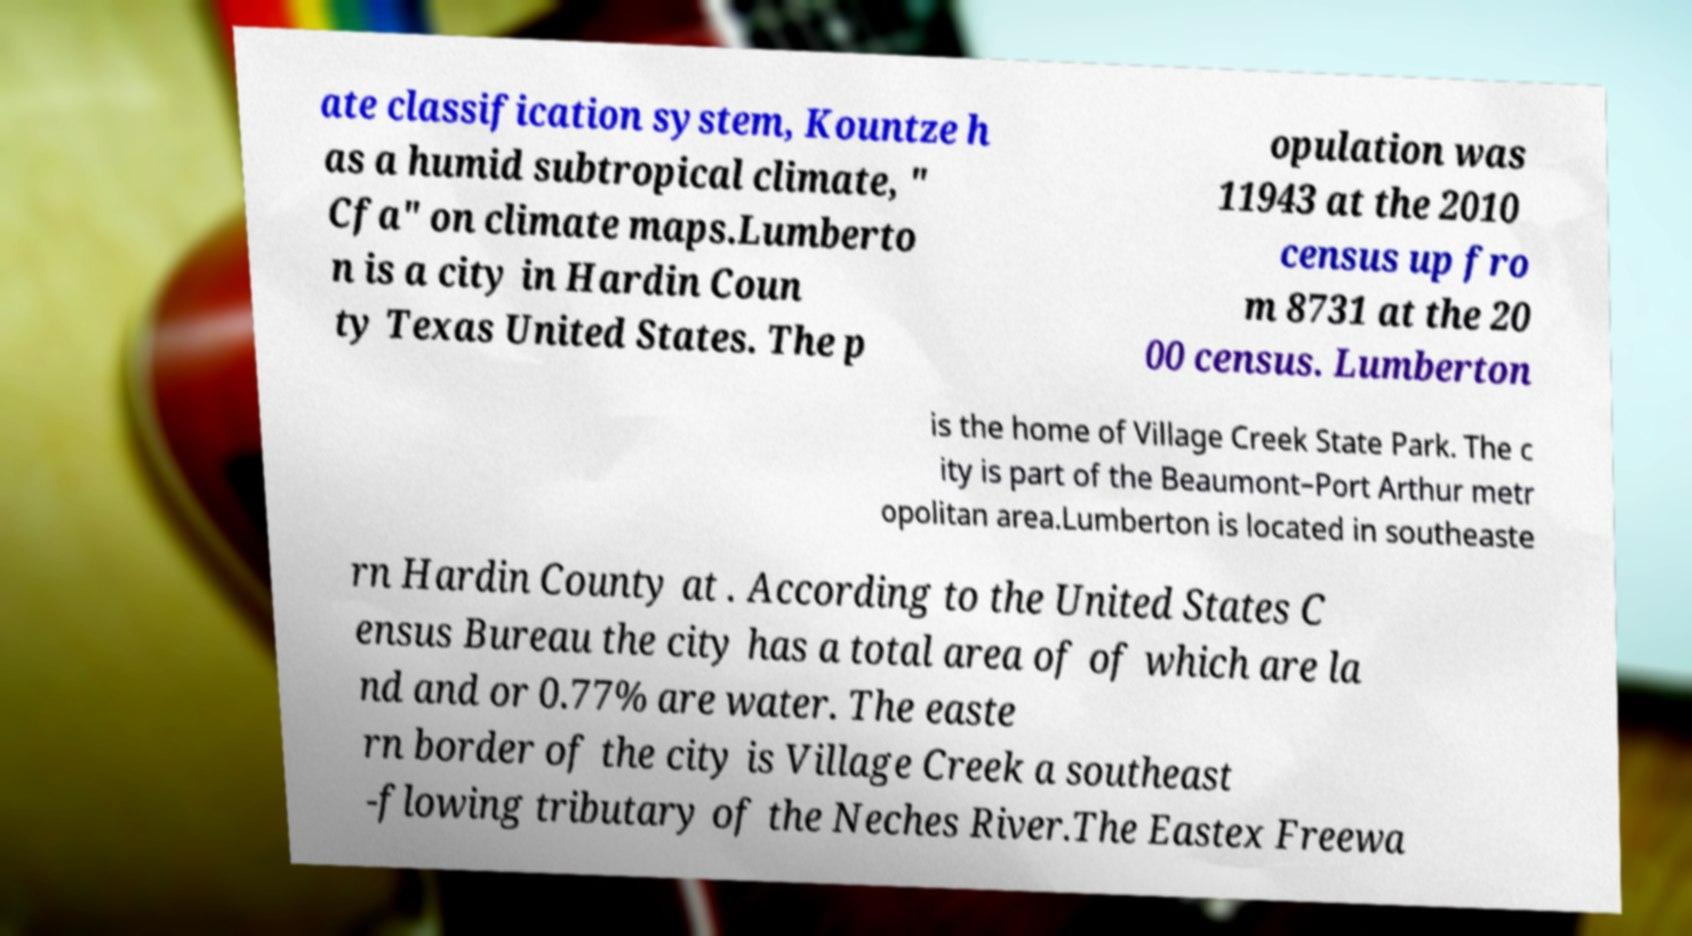Please read and relay the text visible in this image. What does it say? ate classification system, Kountze h as a humid subtropical climate, " Cfa" on climate maps.Lumberto n is a city in Hardin Coun ty Texas United States. The p opulation was 11943 at the 2010 census up fro m 8731 at the 20 00 census. Lumberton is the home of Village Creek State Park. The c ity is part of the Beaumont–Port Arthur metr opolitan area.Lumberton is located in southeaste rn Hardin County at . According to the United States C ensus Bureau the city has a total area of of which are la nd and or 0.77% are water. The easte rn border of the city is Village Creek a southeast -flowing tributary of the Neches River.The Eastex Freewa 